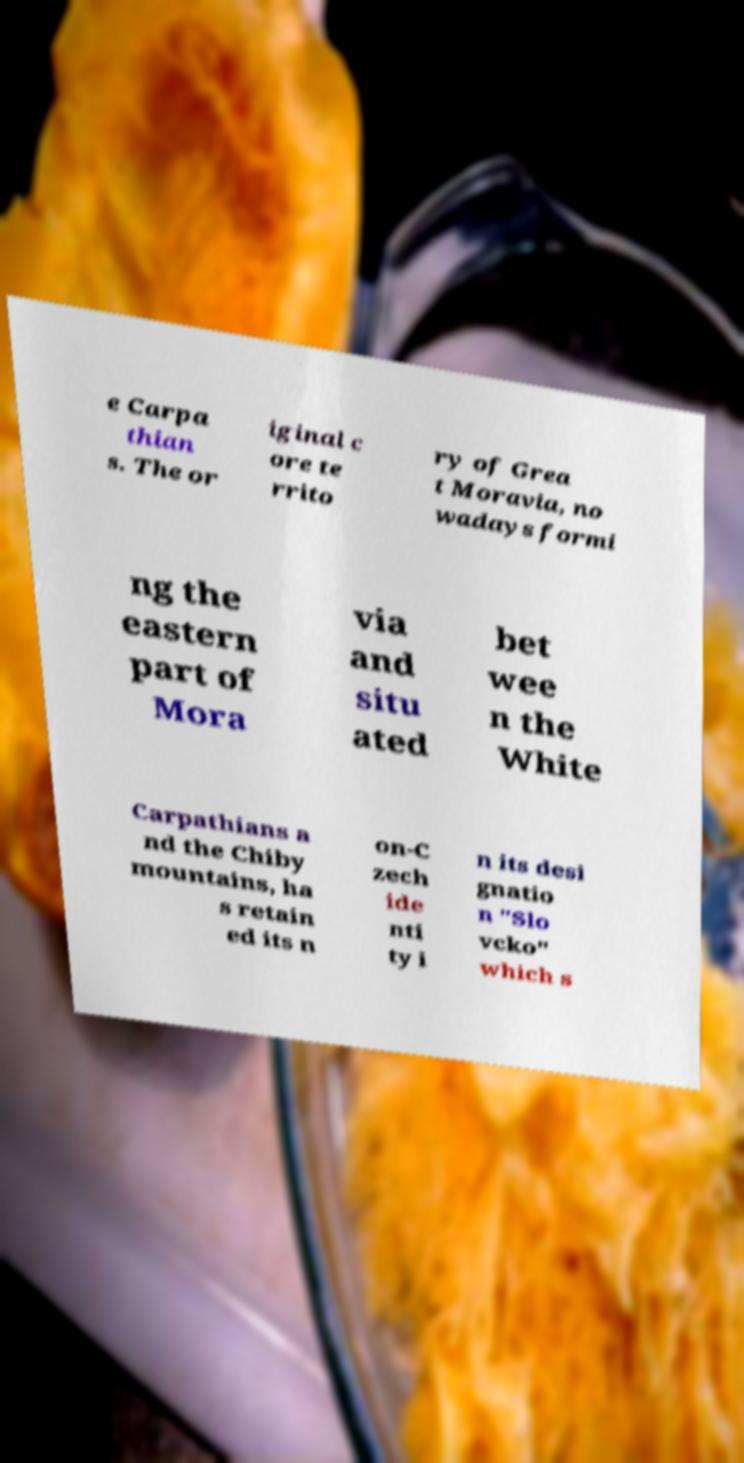For documentation purposes, I need the text within this image transcribed. Could you provide that? e Carpa thian s. The or iginal c ore te rrito ry of Grea t Moravia, no wadays formi ng the eastern part of Mora via and situ ated bet wee n the White Carpathians a nd the Chiby mountains, ha s retain ed its n on-C zech ide nti ty i n its desi gnatio n "Slo vcko" which s 